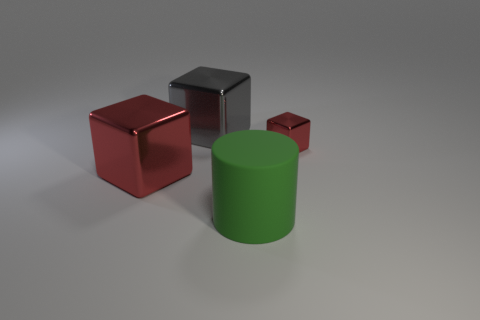What number of large things are red spheres or green rubber cylinders?
Your answer should be compact. 1. There is a metal thing that is in front of the big gray shiny cube and on the left side of the large green matte cylinder; what size is it?
Your response must be concise. Large. There is a big red metal cube; how many matte cylinders are right of it?
Give a very brief answer. 1. What shape is the large object that is both in front of the tiny red shiny object and behind the large green object?
Offer a terse response. Cube. What is the material of the large block that is the same color as the tiny cube?
Offer a terse response. Metal. How many balls are big red metal things or big green matte objects?
Offer a terse response. 0. There is another object that is the same color as the small object; what is its size?
Your answer should be compact. Large. Is the number of cylinders behind the gray shiny cube less than the number of cubes?
Your answer should be very brief. Yes. What is the color of the thing that is right of the gray metal object and in front of the small shiny block?
Make the answer very short. Green. How many other objects are the same shape as the green matte object?
Offer a very short reply. 0. 